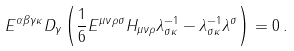Convert formula to latex. <formula><loc_0><loc_0><loc_500><loc_500>E ^ { \alpha \beta \gamma \kappa } D _ { \gamma } \left ( \frac { 1 } { 6 } E ^ { \mu \nu \rho \sigma } H _ { \mu \nu \rho } \lambda _ { \sigma \kappa } ^ { - 1 } - \lambda _ { \sigma \kappa } ^ { - 1 } \lambda ^ { \sigma } \right ) = 0 \, .</formula> 